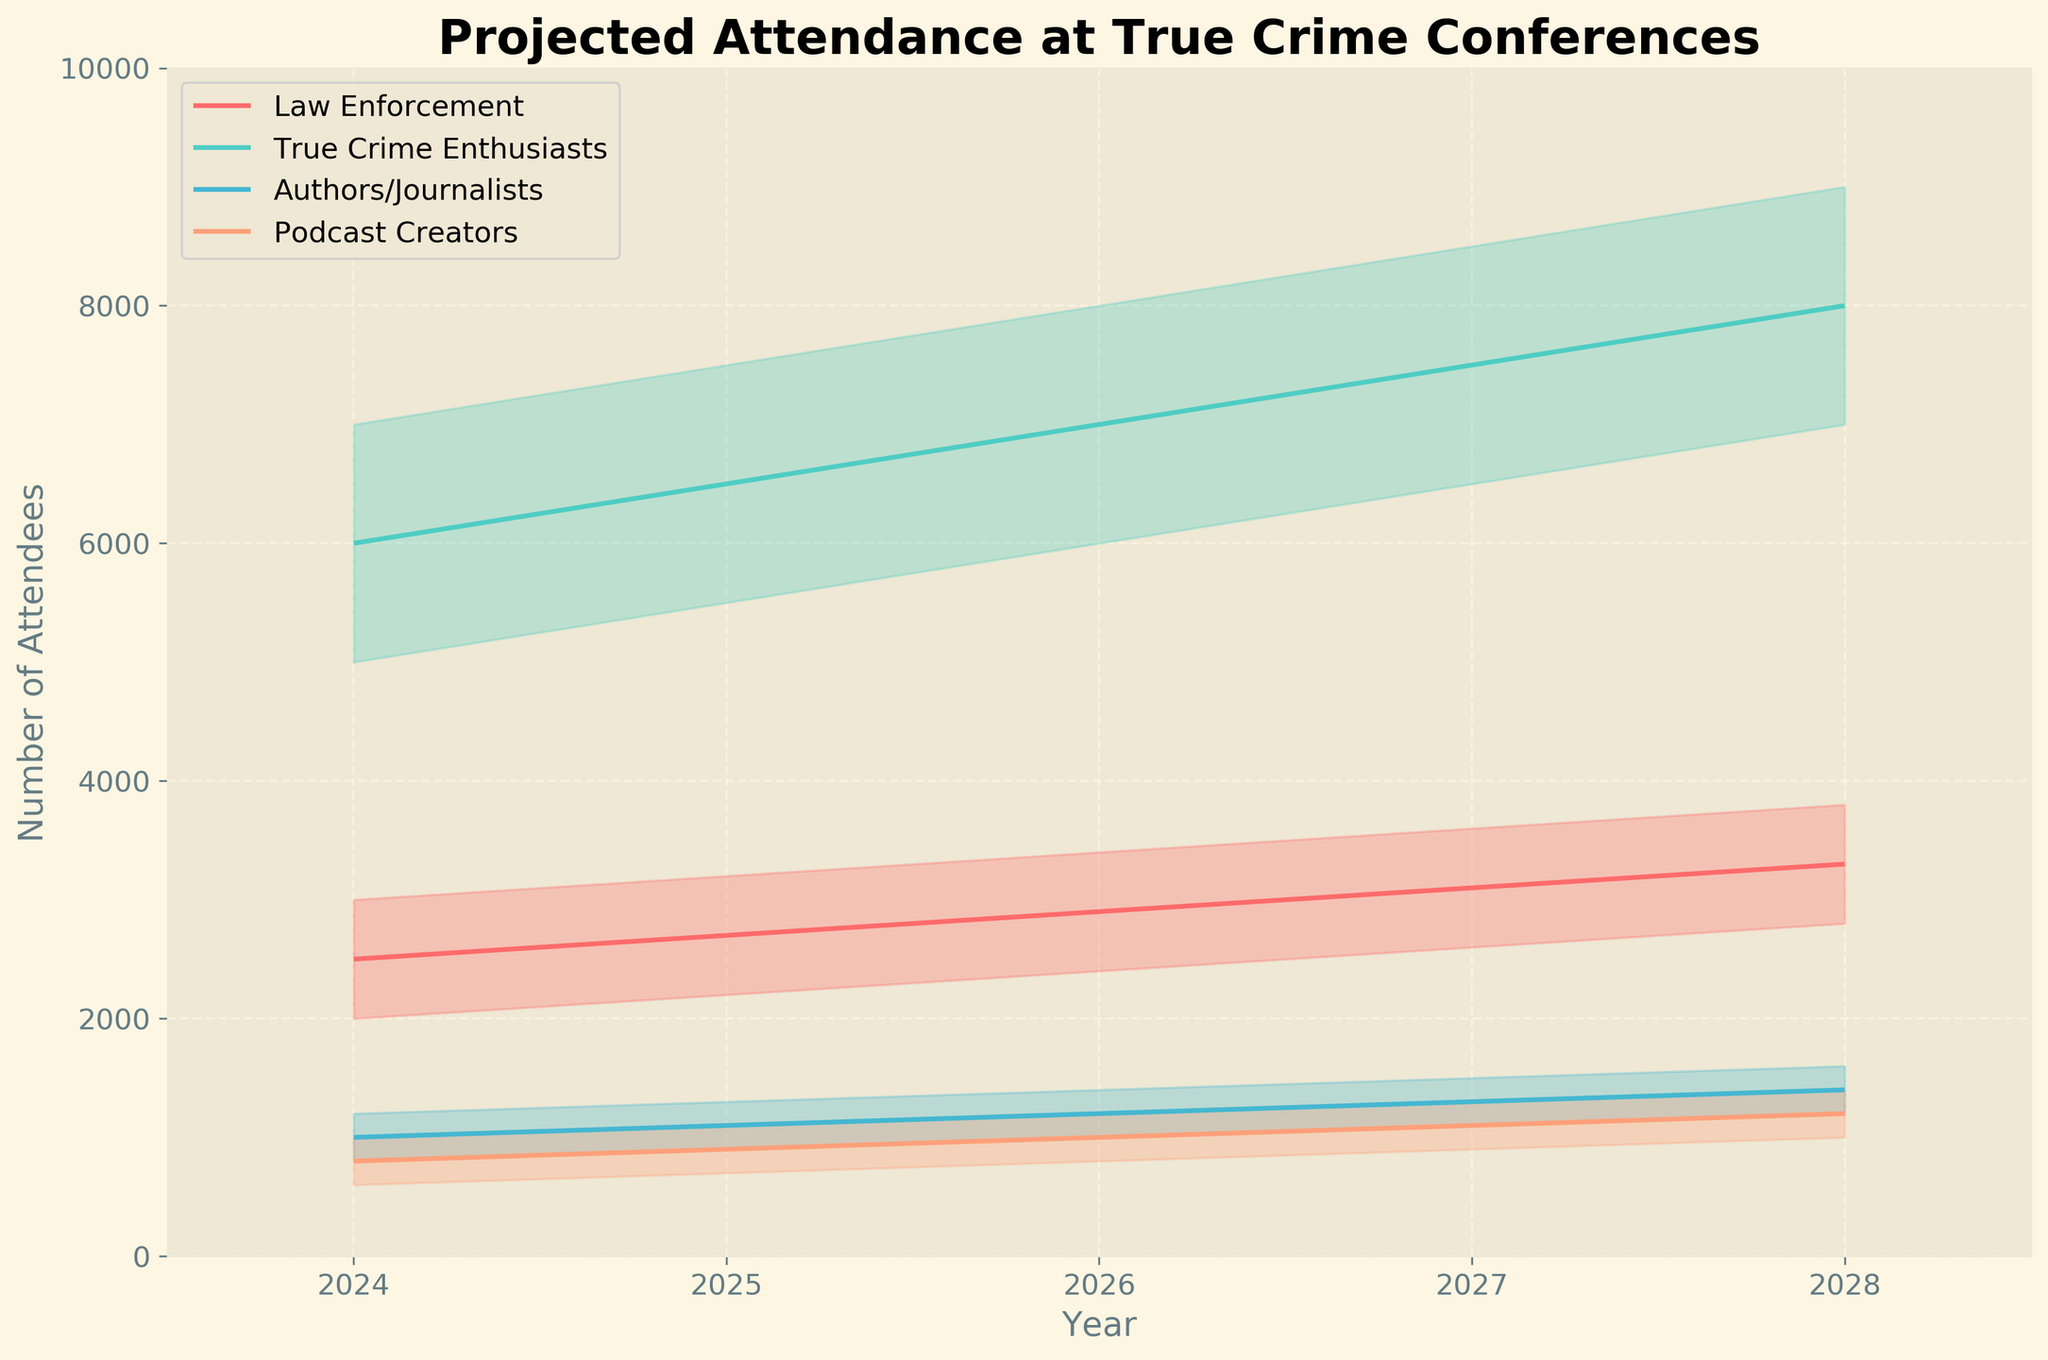What is the title of the figure? The title of the figure is written at the top, typically in a larger font and bold to make it easily noticeable.
Answer: Projected Attendance at True Crime Conferences What attendee type has the highest median estimate in 2024? By looking at the medium estimates for all attendee types in 2024, the True Crime Enthusiasts have the highest median estimate.
Answer: True Crime Enthusiasts How many different attendee types are represented in the figure? The legend or the plot lines that differentiate categories show the number of attendee types represented.
Answer: 4 In 2025, how does the high estimate for Authors/Journalists compare to the low estimate for True Crime Enthusiasts? Check the high estimate for Authors/Journalists and the low estimate for True Crime Enthusiasts in 2025. Authors/Journalists’ high estimate is 1300, and True Crime Enthusiasts' low estimate is 5500. 1300 is much less than 5500.
Answer: Less than Which year shows the highest high estimate for True Crime Enthusiasts? By observing the upper bounds of the bands corresponding to True Crime Enthusiasts over the years, 2028 shows the highest estimate.
Answer: 2028 What is the range of attendance estimates (low to high) for Law Enforcement in 2026? Look at the low and high estimates for Law Enforcement in 2026 and calculate the difference. It ranges from 2400 to 3400.
Answer: 2400 - 3400 How do the median estimates of Podcast Creators change from 2024 to 2028? Track the middle lines for Podcast Creators from 2024 to 2028. The estimates increase from 800 in 2024 to 1200 in 2028.
Answer: Increase Which attendee type has the narrowest range (difference between high and low estimates) in 2027? Calculate the differences between high and low estimates for all attendee types in 2027. True Crime Enthusiasts have the narrowest range of 2000 (8500-6500).
Answer: True Crime Enthusiasts In 2028, which attendee type has the smallest high estimate? Compare the high estimates for all attendee types in 2028. Podcast Creators have the smallest high estimate of 1400.
Answer: Podcast Creators 